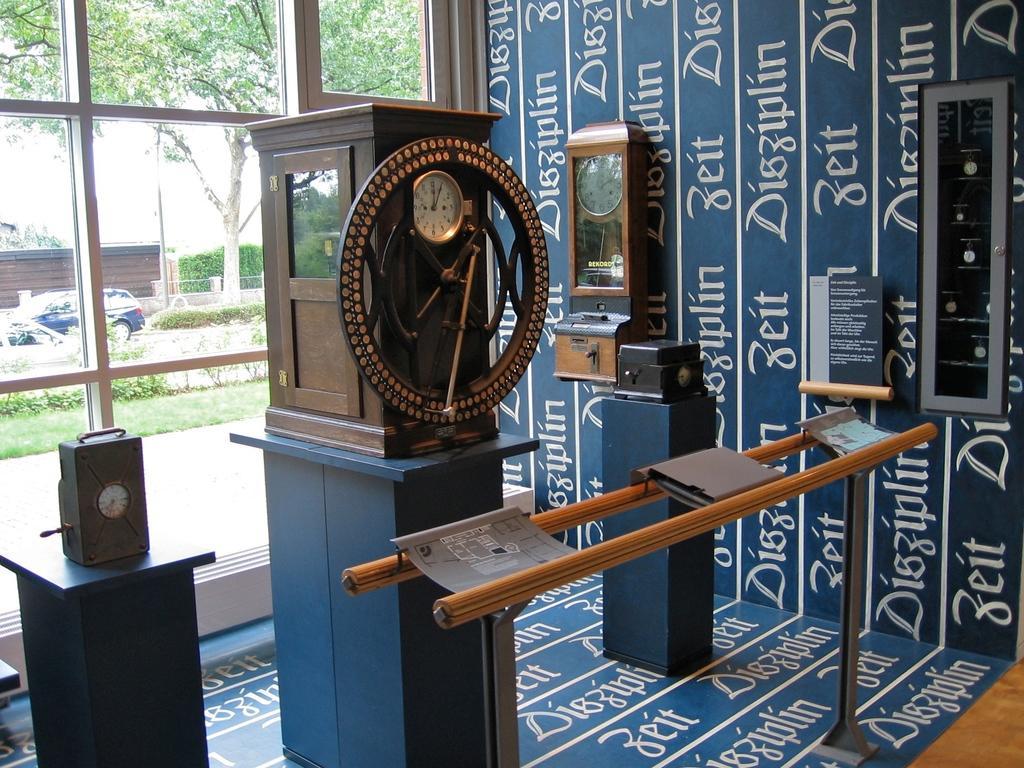Please provide a concise description of this image. In this picture we can see objects on the stand and some text written on the floor and wall. We can see devices on stands. In the background of the image we can see clock in a box, object and glass, through this glass we can see plants, grass, cars, trees and pole. 